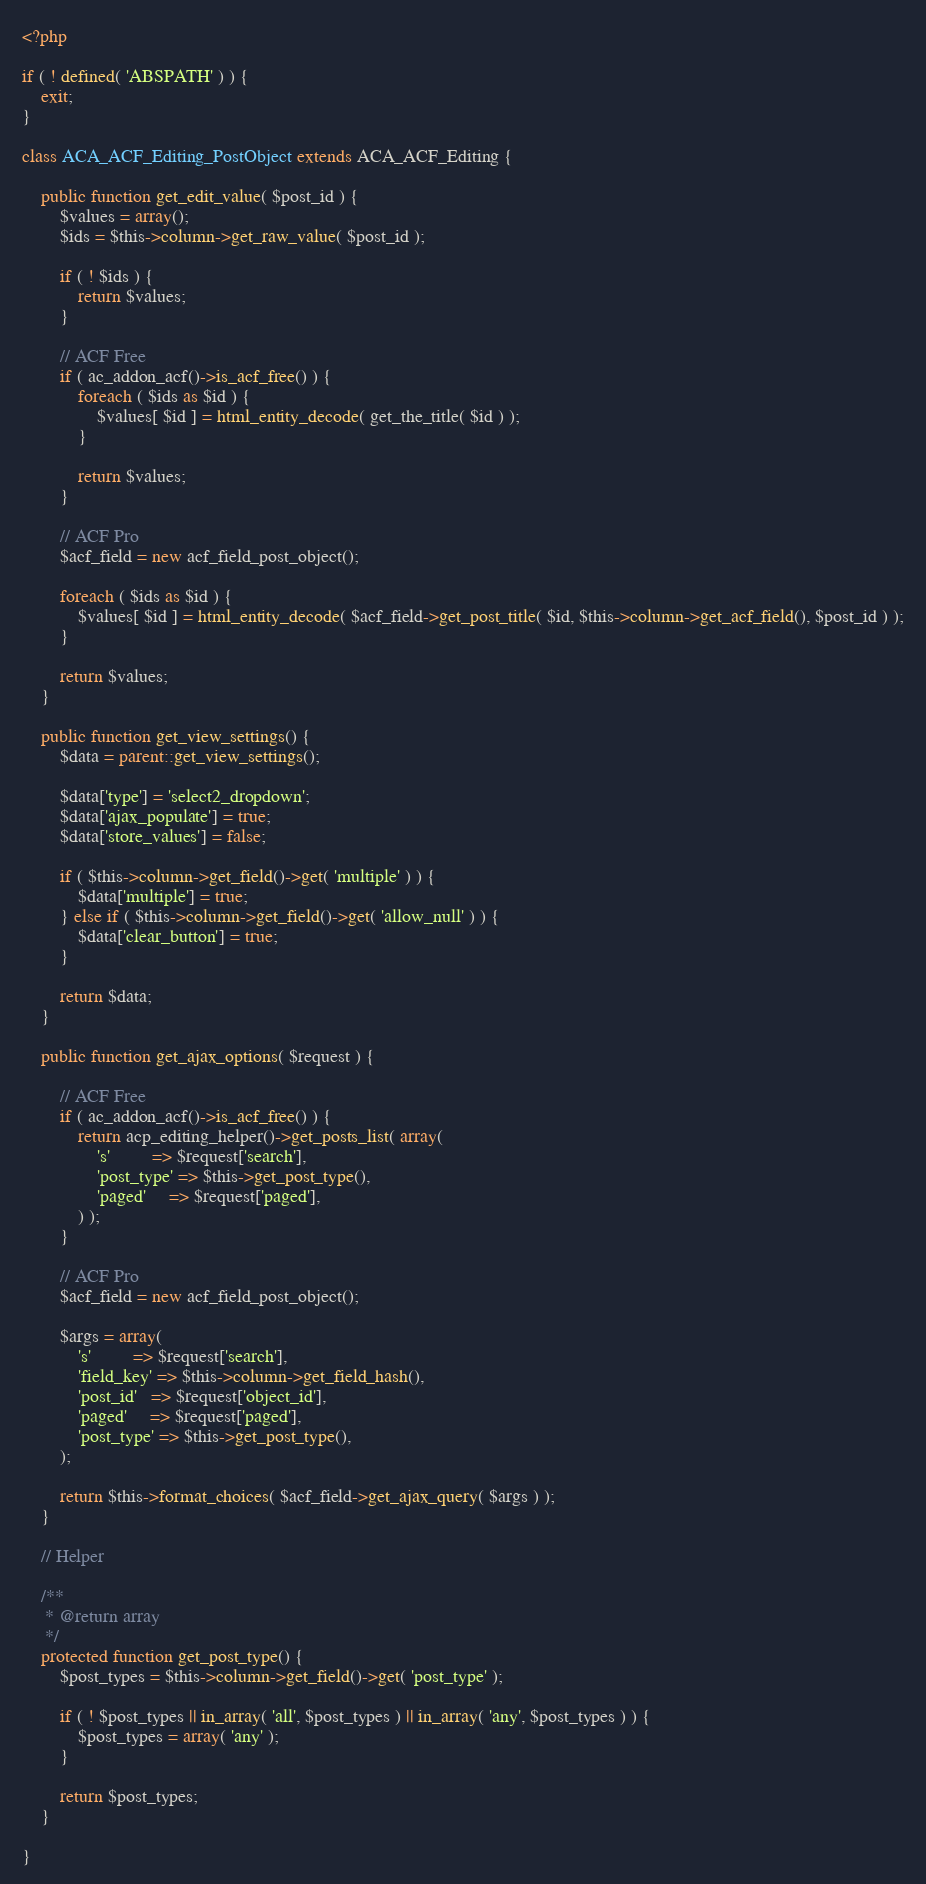<code> <loc_0><loc_0><loc_500><loc_500><_PHP_><?php

if ( ! defined( 'ABSPATH' ) ) {
	exit;
}

class ACA_ACF_Editing_PostObject extends ACA_ACF_Editing {

	public function get_edit_value( $post_id ) {
		$values = array();
		$ids = $this->column->get_raw_value( $post_id );

		if ( ! $ids ) {
			return $values;
		}

		// ACF Free
		if ( ac_addon_acf()->is_acf_free() ) {
			foreach ( $ids as $id ) {
				$values[ $id ] = html_entity_decode( get_the_title( $id ) );
			}

			return $values;
		}

		// ACF Pro
		$acf_field = new acf_field_post_object();

		foreach ( $ids as $id ) {
			$values[ $id ] = html_entity_decode( $acf_field->get_post_title( $id, $this->column->get_acf_field(), $post_id ) );
		}

		return $values;
	}

	public function get_view_settings() {
		$data = parent::get_view_settings();

		$data['type'] = 'select2_dropdown';
		$data['ajax_populate'] = true;
		$data['store_values'] = false;

		if ( $this->column->get_field()->get( 'multiple' ) ) {
			$data['multiple'] = true;
		} else if ( $this->column->get_field()->get( 'allow_null' ) ) {
			$data['clear_button'] = true;
		}

		return $data;
	}

	public function get_ajax_options( $request ) {

		// ACF Free
		if ( ac_addon_acf()->is_acf_free() ) {
			return acp_editing_helper()->get_posts_list( array(
				's'         => $request['search'],
				'post_type' => $this->get_post_type(),
				'paged'     => $request['paged'],
			) );
		}

		// ACF Pro
		$acf_field = new acf_field_post_object();

		$args = array(
			's'         => $request['search'],
			'field_key' => $this->column->get_field_hash(),
			'post_id'   => $request['object_id'],
			'paged'     => $request['paged'],
			'post_type' => $this->get_post_type(),
		);

		return $this->format_choices( $acf_field->get_ajax_query( $args ) );
	}

	// Helper

	/**
	 * @return array
	 */
	protected function get_post_type() {
		$post_types = $this->column->get_field()->get( 'post_type' );

		if ( ! $post_types || in_array( 'all', $post_types ) || in_array( 'any', $post_types ) ) {
			$post_types = array( 'any' );
		}

		return $post_types;
	}

}
</code> 